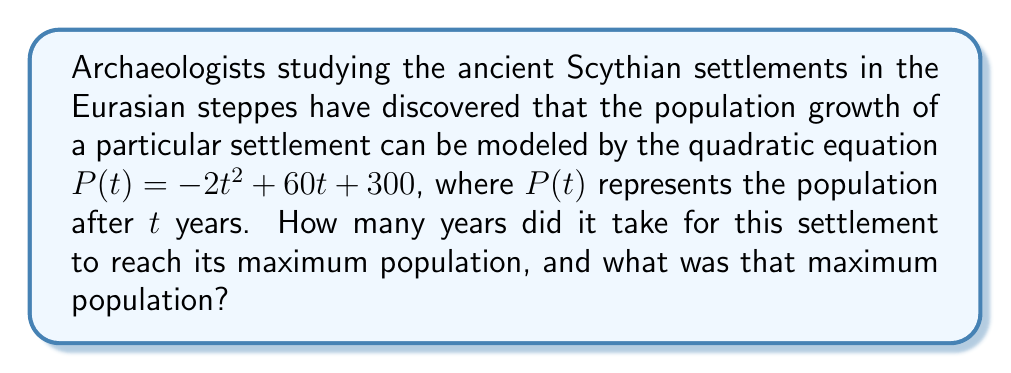Teach me how to tackle this problem. To solve this problem, we'll follow these steps:

1) The population function $P(t) = -2t^2 + 60t + 300$ is a quadratic equation in the form $f(x) = ax^2 + bx + c$, where $a = -2$, $b = 60$, and $c = 300$.

2) For a quadratic function, the maximum (or minimum) point occurs at the vertex of the parabola. Since $a$ is negative, this parabola opens downward and will have a maximum point.

3) To find the t-coordinate of the vertex, we use the formula $t = -\frac{b}{2a}$:

   $t = -\frac{60}{2(-2)} = -\frac{60}{-4} = 15$

4) This means the population reaches its maximum after 15 years.

5) To find the maximum population, we substitute $t = 15$ into the original equation:

   $P(15) = -2(15)^2 + 60(15) + 300$
   $= -2(225) + 900 + 300$
   $= -450 + 900 + 300$
   $= 750$

Therefore, the maximum population of 750 people was reached after 15 years.
Answer: 15 years; 750 people 